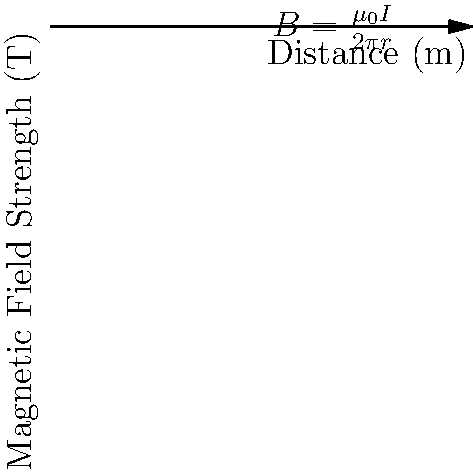In your theological studies, you've encountered the concept of divine omnipresence. Drawing a parallel to physics, consider a long, straight wire carrying a current of 5 amperes. Using the equation $B = \frac{\mu_0 I}{2\pi r}$, where $\mu_0 = 4\pi \times 10^{-7}$ T⋅m/A, calculate the magnetic field strength at a distance of 0.02 meters from the wire. How does this relate to the concept of God's presence diminishing with distance? Let's approach this step-by-step:

1) We are given the equation $B = \frac{\mu_0 I}{2\pi r}$, where:
   $B$ is the magnetic field strength
   $\mu_0$ is the permeability of free space ($4\pi \times 10^{-7}$ T⋅m/A)
   $I$ is the current (5 A)
   $r$ is the distance from the wire (0.02 m)

2) Let's substitute these values into the equation:

   $B = \frac{(4\pi \times 10^{-7})(5)}{2\pi(0.02)}$

3) Simplify:
   $B = \frac{20\pi \times 10^{-7}}{0.04\pi}$

4) Cancel out $\pi$:
   $B = \frac{20 \times 10^{-7}}{0.04}$

5) Divide:
   $B = 5 \times 10^{-5}$ T

This result shows that the magnetic field strength decreases with distance, similar to how some might perceive God's presence as less tangible when they feel distant from Him. However, just as the field never truly reaches zero, one could argue that God's presence, while perhaps less perceptible, remains constant regardless of our perceived distance.
Answer: $5 \times 10^{-5}$ T 